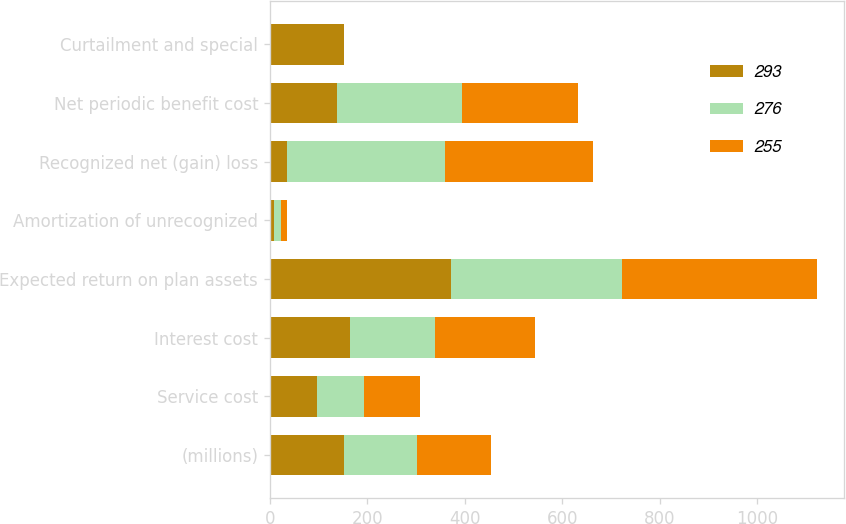<chart> <loc_0><loc_0><loc_500><loc_500><stacked_bar_chart><ecel><fcel>(millions)<fcel>Service cost<fcel>Interest cost<fcel>Expected return on plan assets<fcel>Amortization of unrecognized<fcel>Recognized net (gain) loss<fcel>Net periodic benefit cost<fcel>Curtailment and special<nl><fcel>293<fcel>151<fcel>96<fcel>164<fcel>371<fcel>9<fcel>36<fcel>138<fcel>151<nl><fcel>276<fcel>151<fcel>98<fcel>174<fcel>352<fcel>13<fcel>323<fcel>256<fcel>1<nl><fcel>255<fcel>151<fcel>114<fcel>206<fcel>399<fcel>13<fcel>303<fcel>237<fcel>1<nl></chart> 